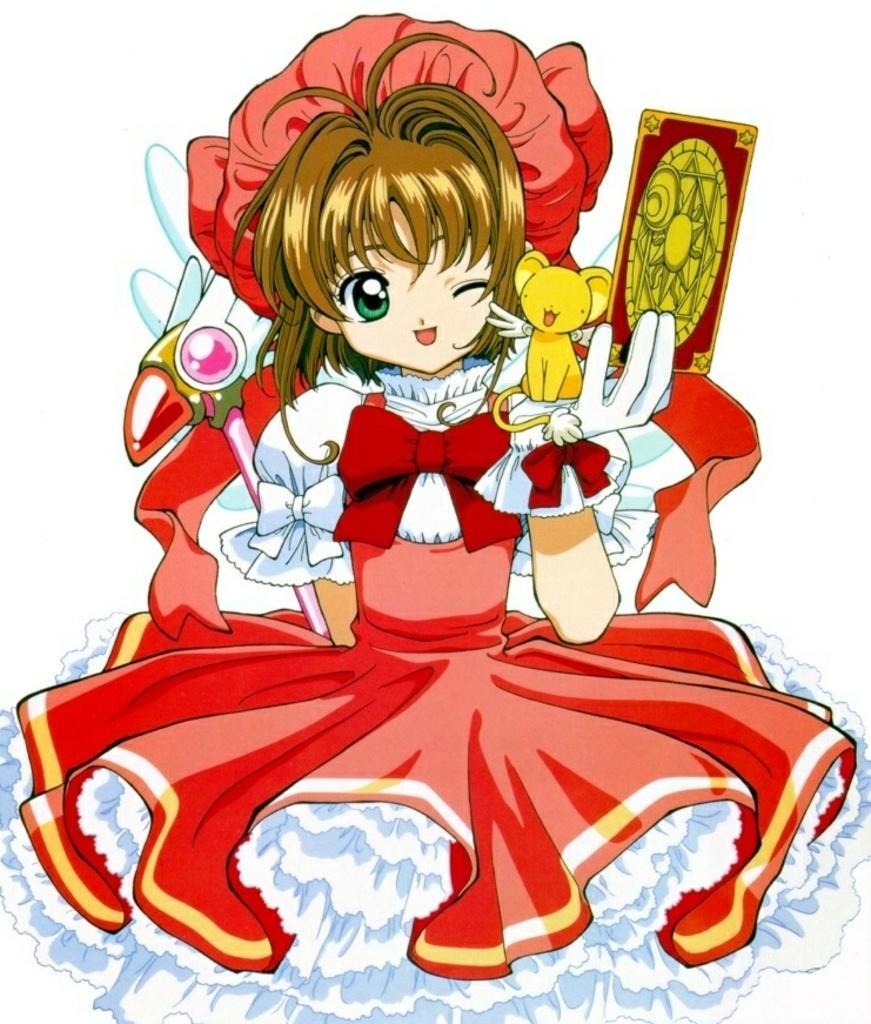How would you summarize this image in a sentence or two? This is an animated image. In the center there is a woman holding some objects, wearing a red color frock and we can see a yellow color animal seems to be sitting on the hand of a woman. The background of the image is white in color. 